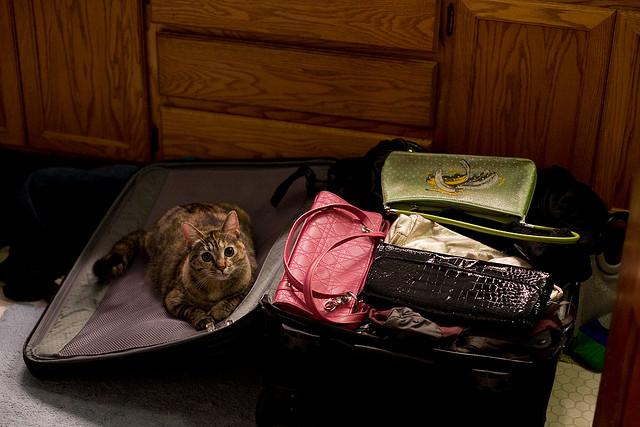What color is the purse next to the animal?
Answer briefly. Pink. Is the luggage full?
Answer briefly. Yes. Why is the cat in a bag?
Quick response, please. Relaxing. What animal is sitting on the suitcase?
Keep it brief. Cat. Are the bags on the floor?
Keep it brief. Yes. 